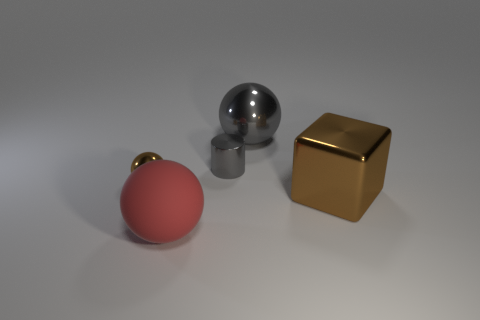There is a brown thing to the right of the gray thing in front of the big metal sphere; what is its material?
Keep it short and to the point. Metal. Does the matte thing have the same shape as the brown thing that is on the left side of the big brown block?
Your answer should be compact. Yes. How many metal objects are tiny brown things or small gray things?
Provide a short and direct response. 2. What is the color of the large ball behind the gray metallic thing that is to the left of the gray metal thing that is on the right side of the small gray object?
Ensure brevity in your answer.  Gray. What number of other objects are the same material as the gray cylinder?
Provide a short and direct response. 3. Does the small thing on the right side of the brown metal sphere have the same shape as the red matte thing?
Your answer should be very brief. No. What number of large objects are gray metal spheres or brown objects?
Ensure brevity in your answer.  2. Are there the same number of brown objects that are in front of the big matte ball and tiny cylinders that are in front of the cylinder?
Your response must be concise. Yes. How many other objects are there of the same color as the tiny shiny sphere?
Make the answer very short. 1. Do the small cylinder and the large metallic thing behind the brown metal block have the same color?
Offer a very short reply. Yes. 